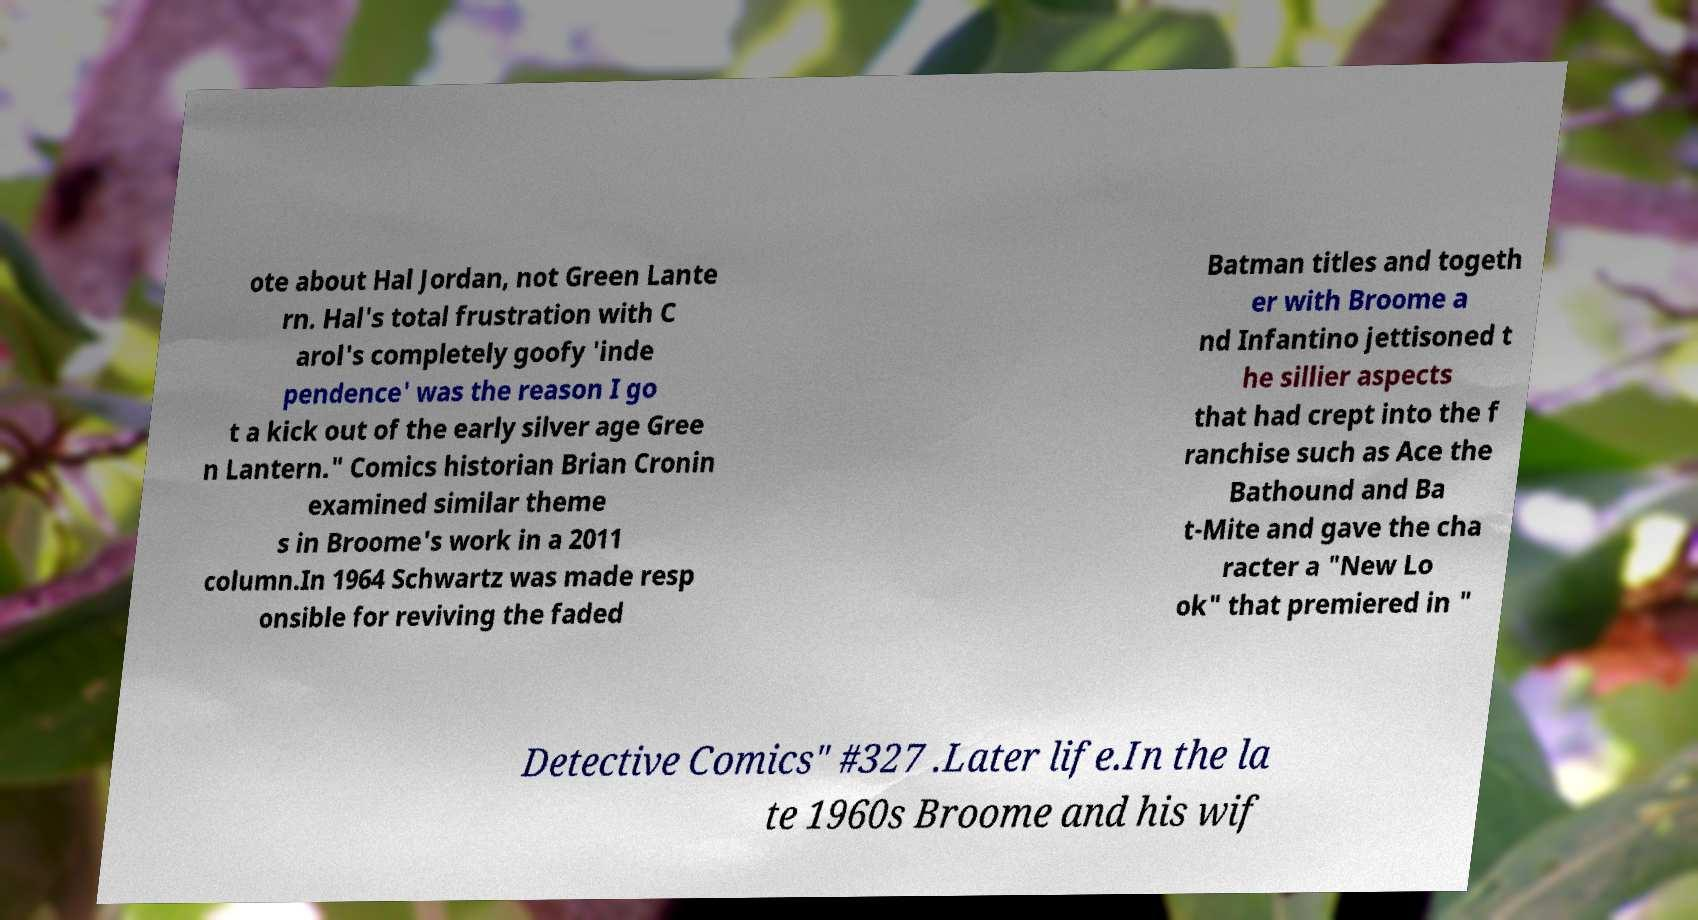For documentation purposes, I need the text within this image transcribed. Could you provide that? ote about Hal Jordan, not Green Lante rn. Hal's total frustration with C arol's completely goofy 'inde pendence' was the reason I go t a kick out of the early silver age Gree n Lantern." Comics historian Brian Cronin examined similar theme s in Broome's work in a 2011 column.In 1964 Schwartz was made resp onsible for reviving the faded Batman titles and togeth er with Broome a nd Infantino jettisoned t he sillier aspects that had crept into the f ranchise such as Ace the Bathound and Ba t-Mite and gave the cha racter a "New Lo ok" that premiered in " Detective Comics" #327 .Later life.In the la te 1960s Broome and his wif 